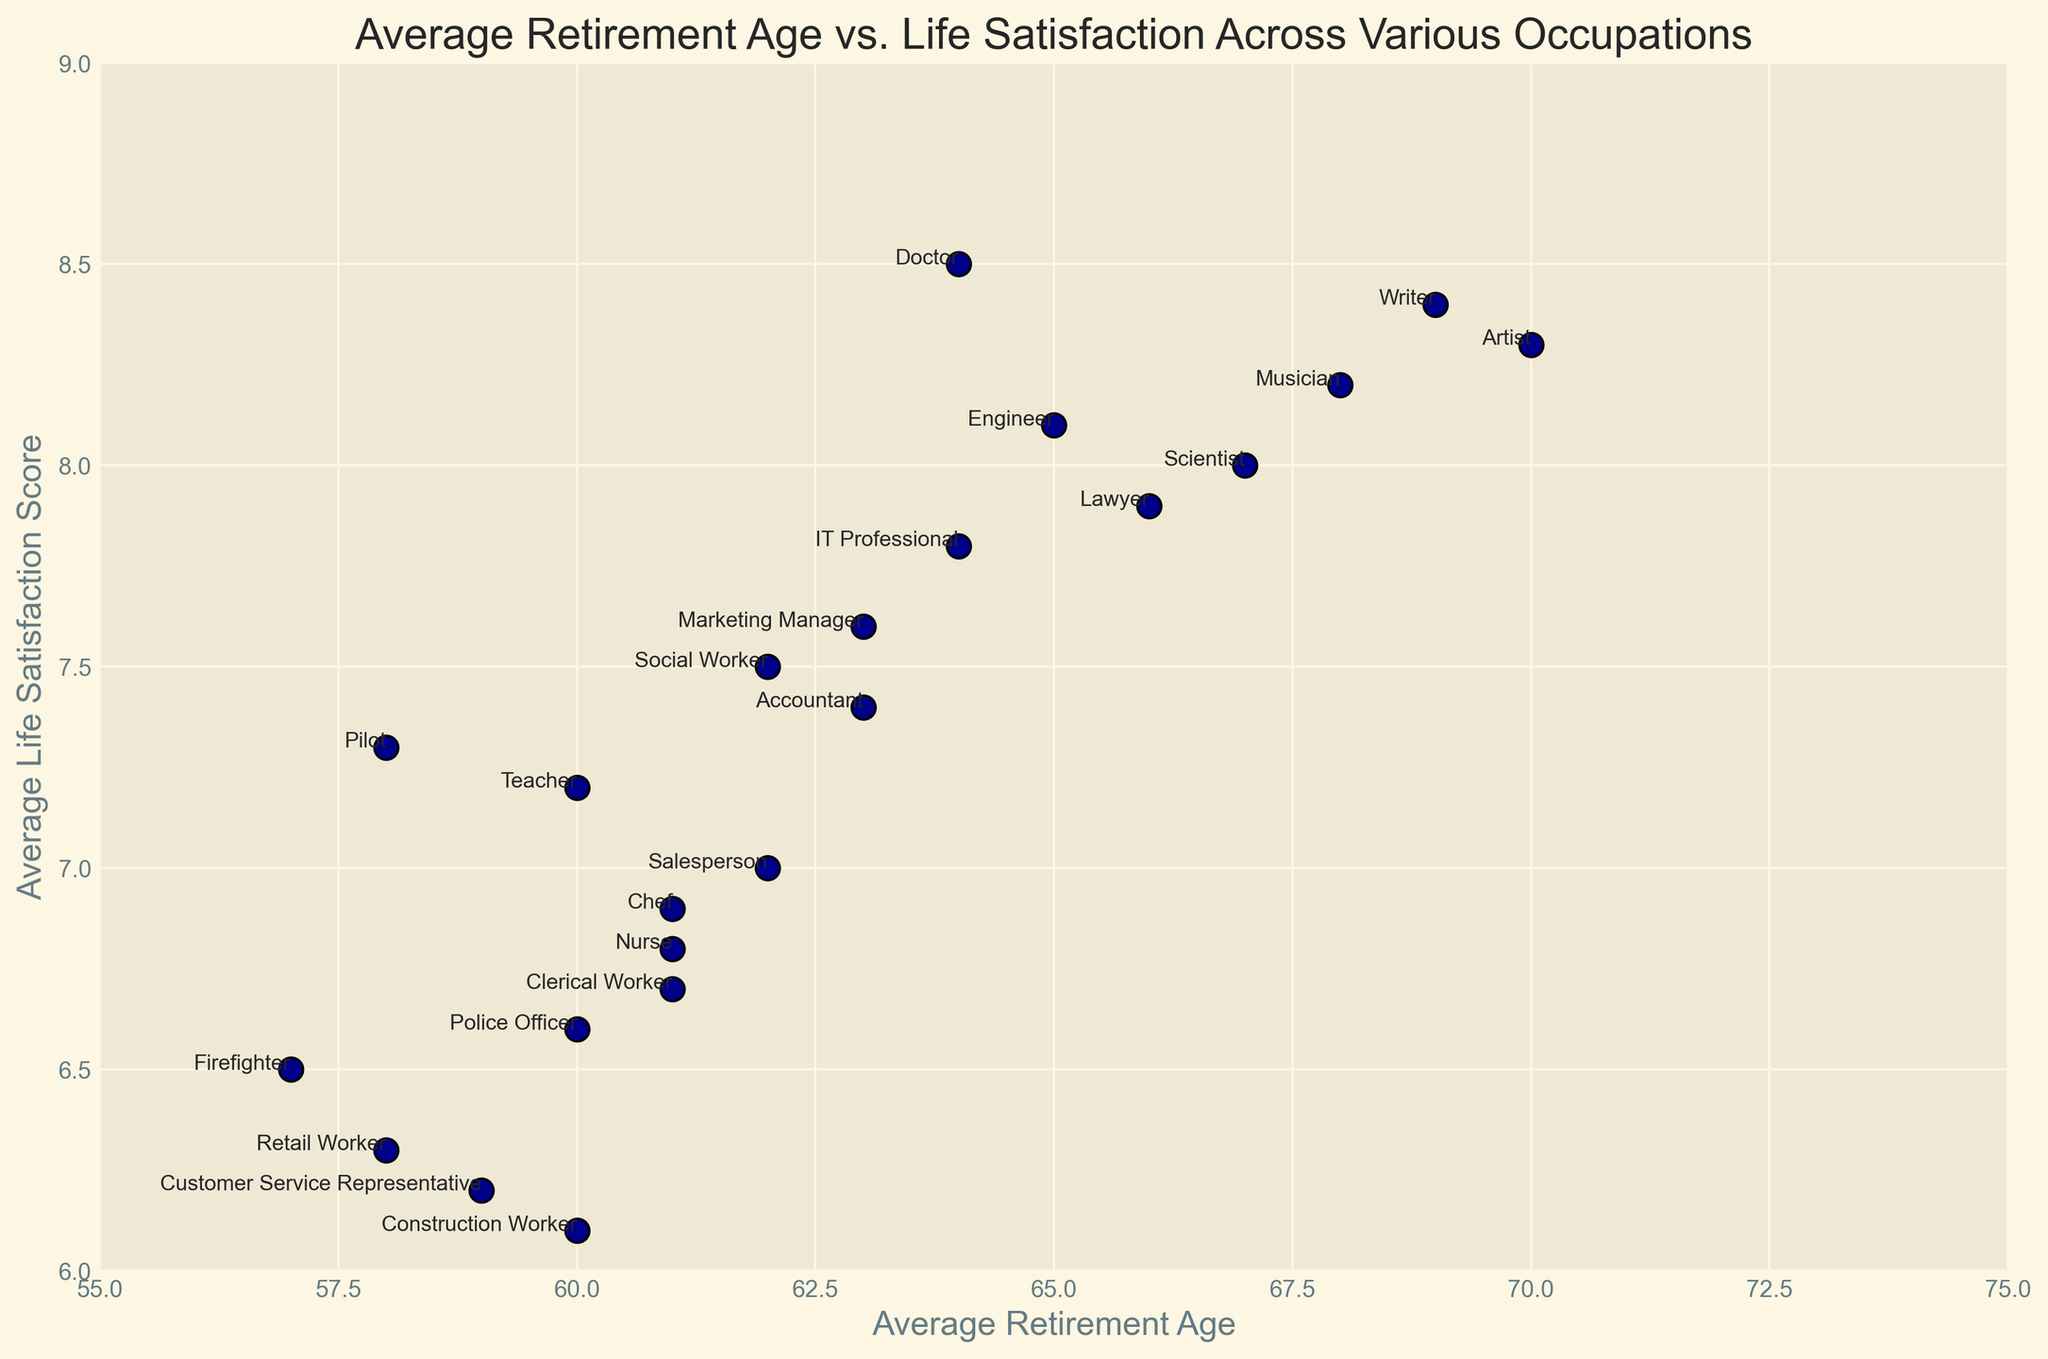Which occupation has the highest life satisfaction score, and what is that score? According to the plot, the "Doctor" occupation has the highest life satisfaction score, marked at the highest point on the y-axis. The score is 8.5.
Answer: Doctor, 8.5 What is the average life satisfaction score for occupations that retire at age 60? The occupations that retire at age 60 are Teacher, Construction Worker, and Police Officer. Their life satisfaction scores are 7.2, 6.1, and 6.6 respectively. The average is calculated as (7.2 + 6.1 + 6.6) / 3, which equals 6.63.
Answer: 6.63 Which occupation retires the earliest and what is their life satisfaction score? According to the scatter plot, "Firefighter" retires the earliest at age 57. The corresponding life satisfaction score is 6.5.
Answer: Firefighter, 6.5 Which occupation has the highest retirement age, and how does their life satisfaction compare to doctors? "Artist" shows the highest retirement age at 70. Comparing their life satisfaction score of 8.3 with doctors' score of 8.5, doctors have a slightly higher score.
Answer: Artist, 8.3 vs Doctor, 8.5 What is the difference in life satisfaction score between Nurses and Musicians? The average life satisfaction score for Nurses is 6.8 and for Musicians is 8.2. The difference is calculated as 8.2 - 6.8, which equals 1.4.
Answer: 1.4 Which profession has a retirement age of 64, and what is their life satisfaction score? According to the plot, "Doctor" and "IT Professional" both retire at age 64. "Doctor" has a life satisfaction score of 8.5 and "IT Professional" has a score of 7.8.
Answer: Doctor 8.5, IT Professional 7.8 Is there a correlation between retirement age and life satisfaction for these occupations? Visually analyzing the scatter plot, it appears that occupations with higher retirement ages tend to have higher life satisfaction scores, indicating a positive correlation.
Answer: Positive correlation What is the median life satisfaction score among all listed occupations? To find the median, we need to list the scores in ascending order: 6.1, 6.2, 6.3, 6.5, 6.6, 6.7, 6.8, 6.9, 7.0, 7.2, 7.3, 7.4, 7.5, 7.6, 7.8, 7.9, 8.0, 8.1, 8.2, 8.3, 8.4, 8.5. The median score, being the middle value in this ordered list, is 7.4.
Answer: 7.4 What is the average retirement age for occupations with a life satisfaction score greater than 8? The occupations with life satisfaction scores greater than 8 are Engineer (65), Doctor (64), Artist (70), Musician (68), and Writer (69). The average retirement age is calculated as (65 + 64 + 70 + 68 + 69) / 5 = 67.2.
Answer: 67.2 